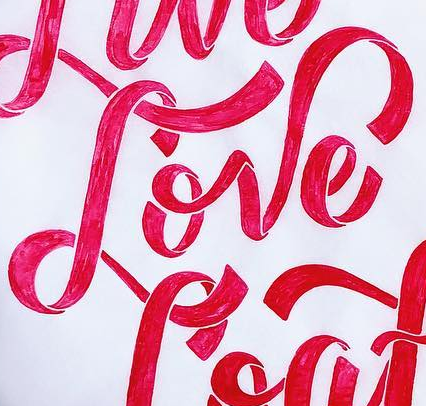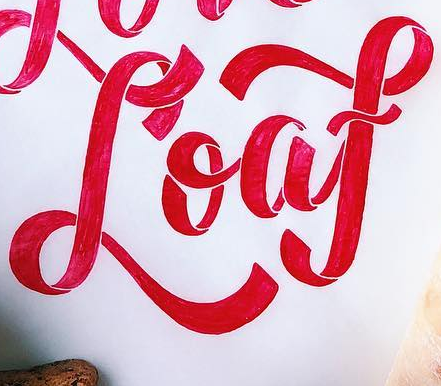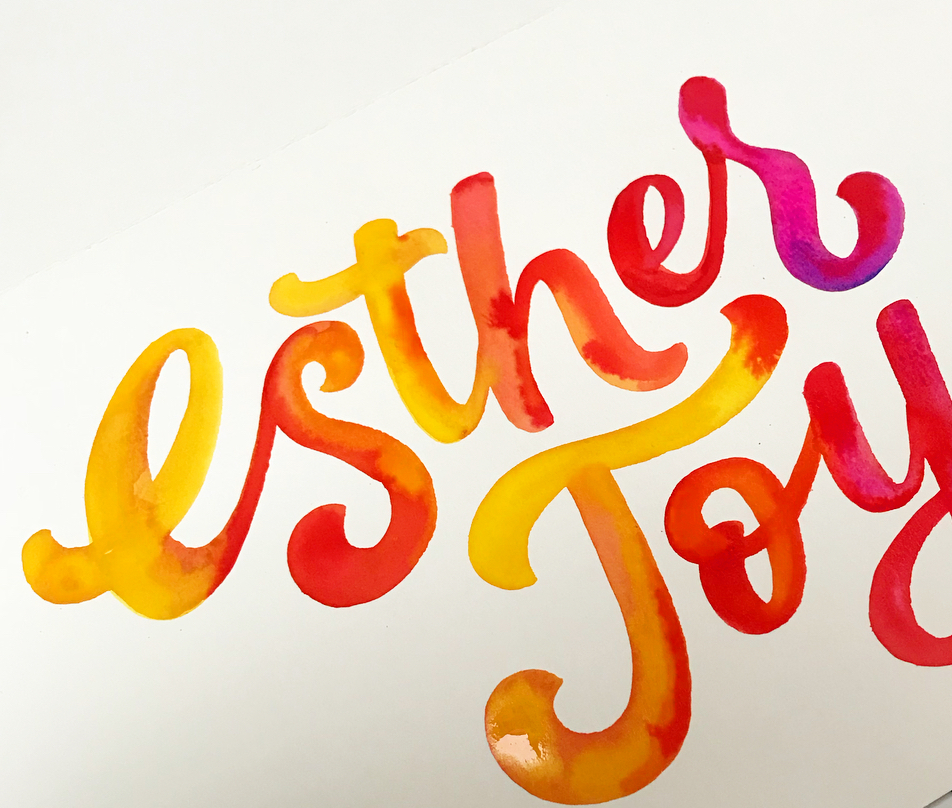Transcribe the words shown in these images in order, separated by a semicolon. Love; Loaf; Esthes 